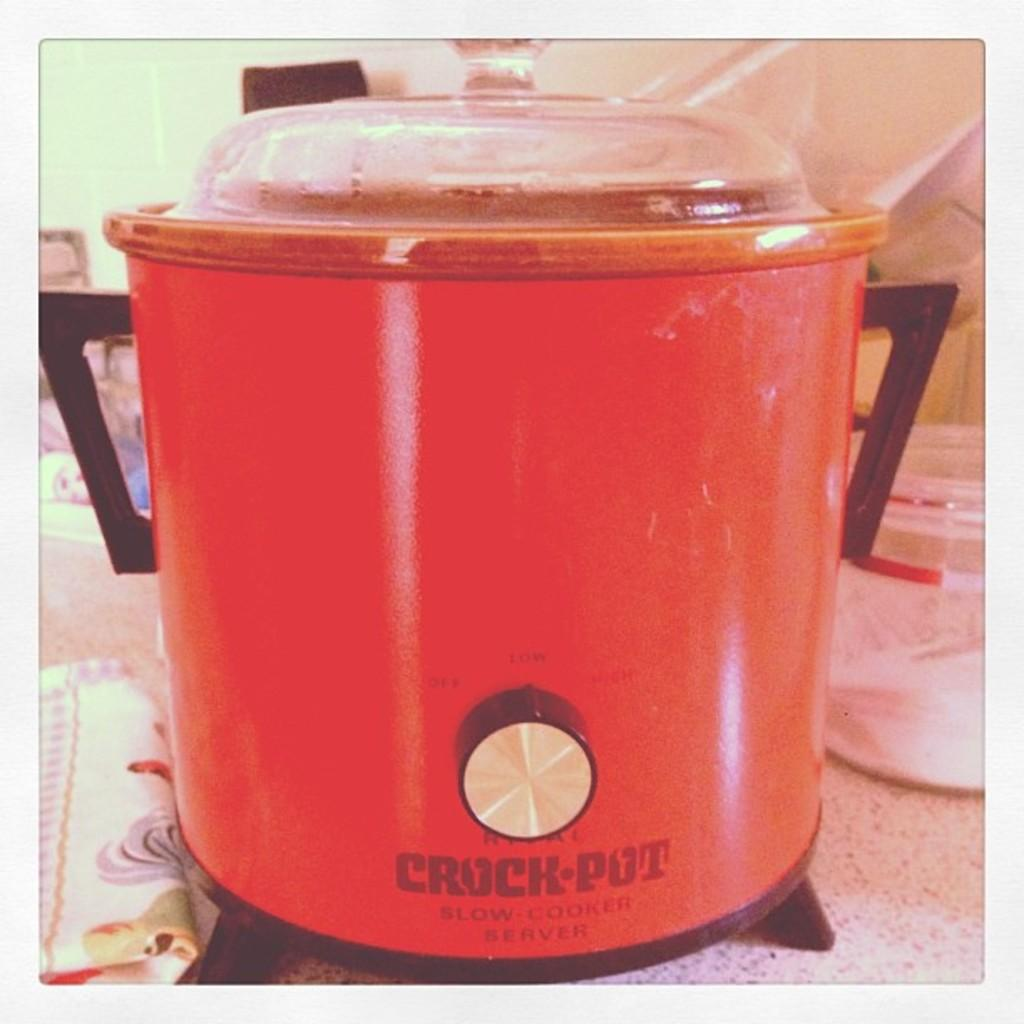What color is the cooker in the image? The cooker in the image is red. Where is the cooker located? The cooker is on a table in the image. What can be seen on the right side of the image? There is a plate on the right side of the image. What is on the left side of the image? There is a cloth on the left side of the image. What type of leather is used to make the quiver in the image? There is no quiver present in the image, so it is not possible to determine the type of leather used. 